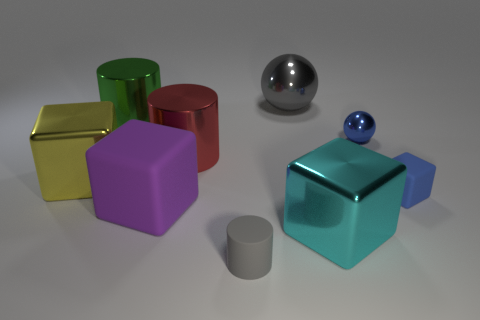Subtract all big green cylinders. How many cylinders are left? 2 Subtract all cyan cubes. How many cubes are left? 3 Subtract all cylinders. How many objects are left? 6 Add 1 small blue blocks. How many objects exist? 10 Subtract 1 cylinders. How many cylinders are left? 2 Subtract 1 red cylinders. How many objects are left? 8 Subtract all brown balls. Subtract all gray cylinders. How many balls are left? 2 Subtract all gray cylinders. How many brown blocks are left? 0 Subtract all gray shiny things. Subtract all tiny green cylinders. How many objects are left? 8 Add 9 red shiny things. How many red shiny things are left? 10 